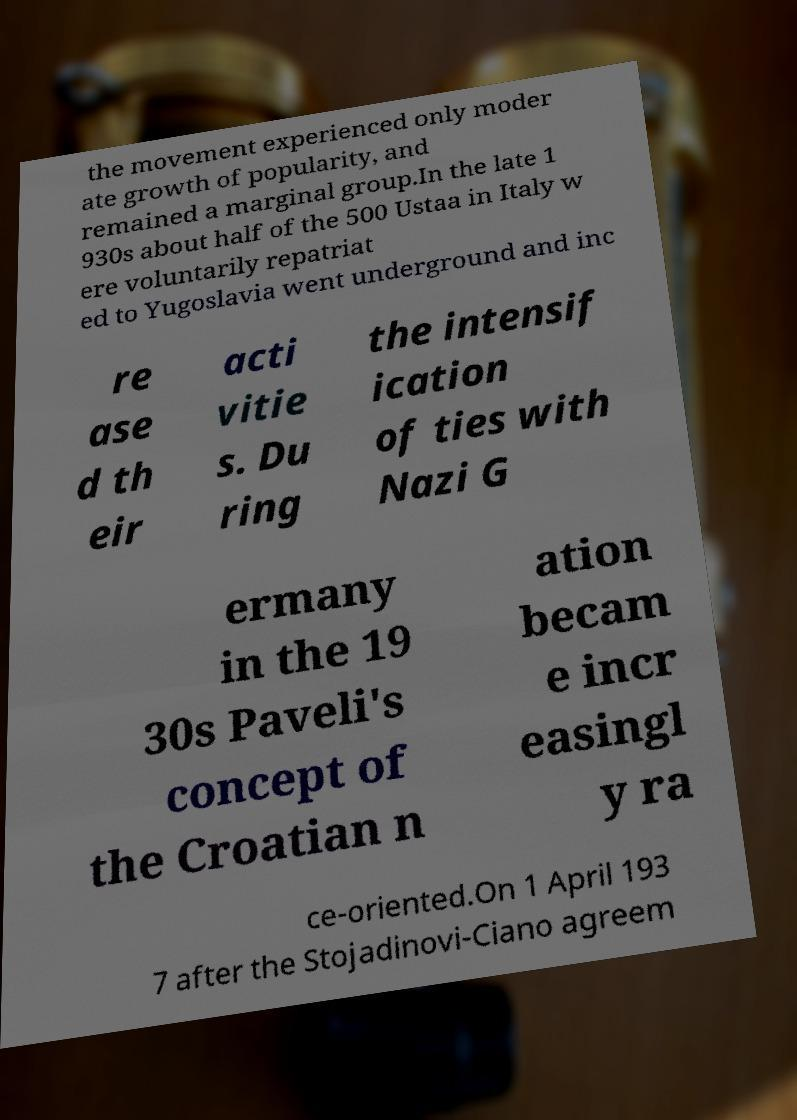There's text embedded in this image that I need extracted. Can you transcribe it verbatim? the movement experienced only moder ate growth of popularity, and remained a marginal group.In the late 1 930s about half of the 500 Ustaa in Italy w ere voluntarily repatriat ed to Yugoslavia went underground and inc re ase d th eir acti vitie s. Du ring the intensif ication of ties with Nazi G ermany in the 19 30s Paveli's concept of the Croatian n ation becam e incr easingl y ra ce-oriented.On 1 April 193 7 after the Stojadinovi-Ciano agreem 